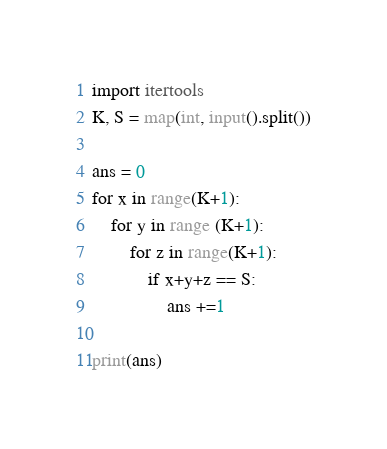Convert code to text. <code><loc_0><loc_0><loc_500><loc_500><_Python_>import itertools
K, S = map(int, input().split())

ans = 0
for x in range(K+1):
    for y in range (K+1):
        for z in range(K+1):
            if x+y+z == S:
                ans +=1

print(ans)</code> 